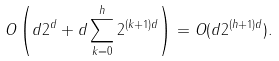<formula> <loc_0><loc_0><loc_500><loc_500>O \left ( d 2 ^ { d } + d \sum _ { k = 0 } ^ { h } { 2 ^ { ( k + 1 ) d } } \right ) = O ( d 2 ^ { ( h + 1 ) d } ) .</formula> 